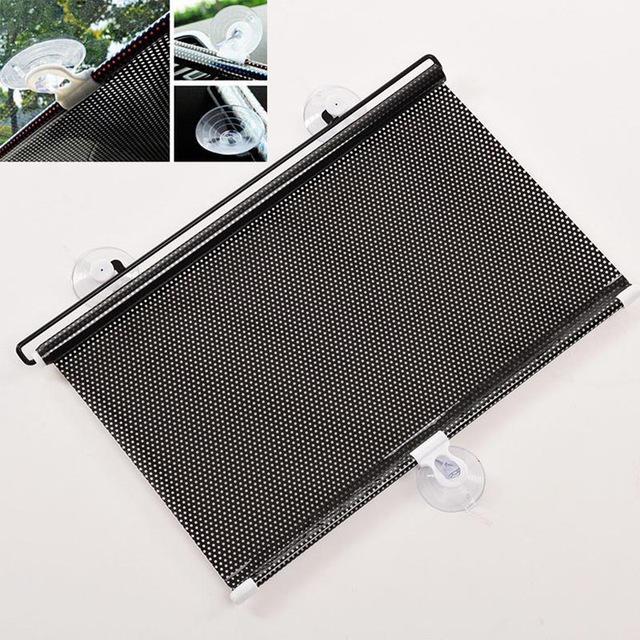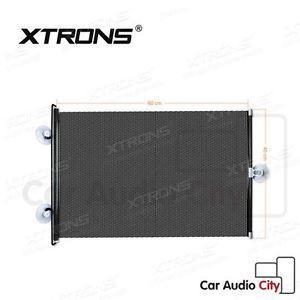The first image is the image on the left, the second image is the image on the right. Analyze the images presented: Is the assertion "At least one hand shows how to adjust a car window shade with two suction cups at the top and one at the bottom." valid? Answer yes or no. No. 